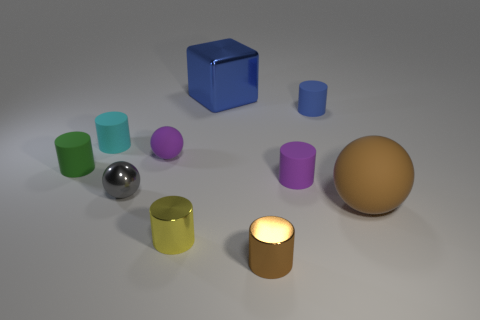Subtract all gray metal balls. How many balls are left? 2 Subtract all brown cylinders. How many cylinders are left? 5 Subtract 4 cylinders. How many cylinders are left? 2 Subtract all cylinders. How many objects are left? 4 Subtract all purple cubes. Subtract all purple cylinders. How many cubes are left? 1 Subtract all tiny blue cylinders. Subtract all small cyan matte cylinders. How many objects are left? 8 Add 9 blue metal things. How many blue metal things are left? 10 Add 4 small blue rubber things. How many small blue rubber things exist? 5 Subtract 0 green cubes. How many objects are left? 10 